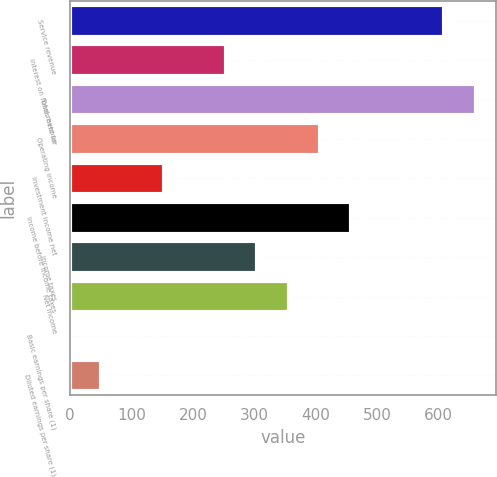Convert chart to OTSL. <chart><loc_0><loc_0><loc_500><loc_500><bar_chart><fcel>Service revenue<fcel>Interest on funds held for<fcel>Total revenue<fcel>Operating income<fcel>Investment income net<fcel>Income before income taxes<fcel>Income taxes<fcel>Net income<fcel>Basic earnings per share (1)<fcel>Diluted earnings per share (1)<nl><fcel>609.31<fcel>254.06<fcel>660.06<fcel>406.31<fcel>152.56<fcel>457.06<fcel>304.81<fcel>355.56<fcel>0.31<fcel>51.06<nl></chart> 